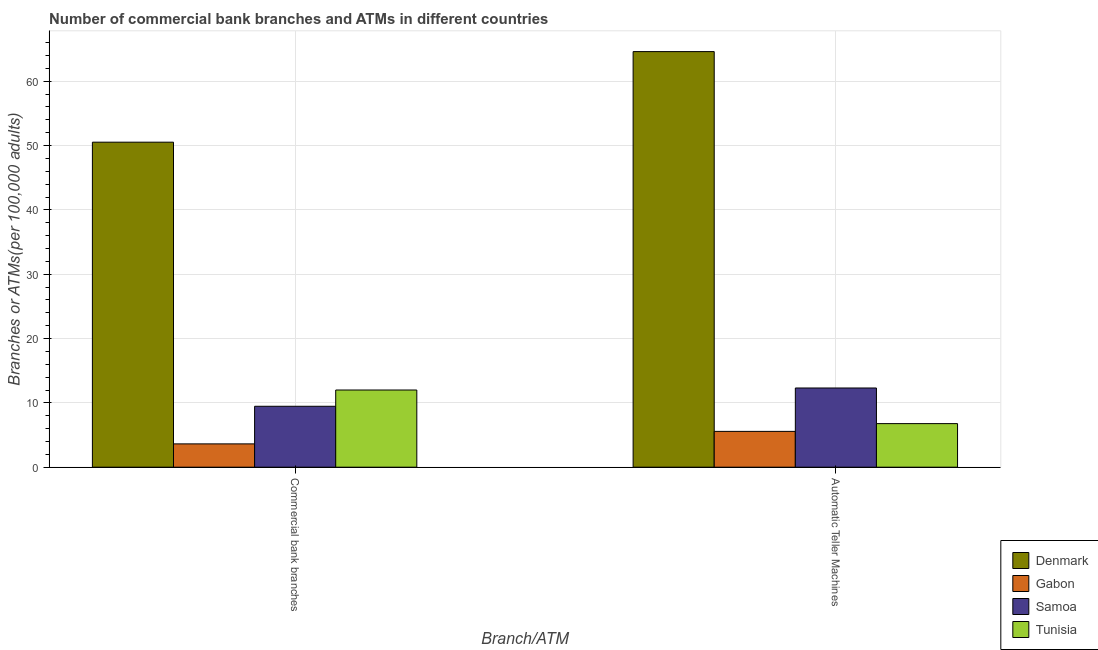How many different coloured bars are there?
Your response must be concise. 4. How many groups of bars are there?
Your answer should be very brief. 2. Are the number of bars per tick equal to the number of legend labels?
Provide a short and direct response. Yes. Are the number of bars on each tick of the X-axis equal?
Your answer should be very brief. Yes. How many bars are there on the 1st tick from the left?
Provide a short and direct response. 4. How many bars are there on the 2nd tick from the right?
Your answer should be very brief. 4. What is the label of the 2nd group of bars from the left?
Ensure brevity in your answer.  Automatic Teller Machines. What is the number of atms in Tunisia?
Provide a succinct answer. 6.78. Across all countries, what is the maximum number of atms?
Give a very brief answer. 64.61. Across all countries, what is the minimum number of atms?
Give a very brief answer. 5.57. In which country was the number of commercal bank branches maximum?
Your response must be concise. Denmark. In which country was the number of atms minimum?
Provide a succinct answer. Gabon. What is the total number of atms in the graph?
Provide a short and direct response. 89.26. What is the difference between the number of commercal bank branches in Denmark and that in Samoa?
Provide a succinct answer. 41.05. What is the difference between the number of atms in Samoa and the number of commercal bank branches in Gabon?
Keep it short and to the point. 8.69. What is the average number of commercal bank branches per country?
Give a very brief answer. 18.91. What is the difference between the number of commercal bank branches and number of atms in Samoa?
Offer a terse response. -2.84. What is the ratio of the number of atms in Tunisia to that in Samoa?
Make the answer very short. 0.55. In how many countries, is the number of atms greater than the average number of atms taken over all countries?
Your answer should be very brief. 1. What does the 1st bar from the left in Automatic Teller Machines represents?
Keep it short and to the point. Denmark. What does the 1st bar from the right in Automatic Teller Machines represents?
Provide a succinct answer. Tunisia. How many bars are there?
Your answer should be very brief. 8. Where does the legend appear in the graph?
Give a very brief answer. Bottom right. What is the title of the graph?
Offer a very short reply. Number of commercial bank branches and ATMs in different countries. Does "Tajikistan" appear as one of the legend labels in the graph?
Your response must be concise. No. What is the label or title of the X-axis?
Keep it short and to the point. Branch/ATM. What is the label or title of the Y-axis?
Offer a terse response. Branches or ATMs(per 100,0 adults). What is the Branches or ATMs(per 100,000 adults) of Denmark in Commercial bank branches?
Give a very brief answer. 50.53. What is the Branches or ATMs(per 100,000 adults) of Gabon in Commercial bank branches?
Keep it short and to the point. 3.62. What is the Branches or ATMs(per 100,000 adults) of Samoa in Commercial bank branches?
Your answer should be very brief. 9.47. What is the Branches or ATMs(per 100,000 adults) in Tunisia in Commercial bank branches?
Offer a terse response. 12. What is the Branches or ATMs(per 100,000 adults) in Denmark in Automatic Teller Machines?
Keep it short and to the point. 64.61. What is the Branches or ATMs(per 100,000 adults) of Gabon in Automatic Teller Machines?
Ensure brevity in your answer.  5.57. What is the Branches or ATMs(per 100,000 adults) in Samoa in Automatic Teller Machines?
Make the answer very short. 12.31. What is the Branches or ATMs(per 100,000 adults) of Tunisia in Automatic Teller Machines?
Keep it short and to the point. 6.78. Across all Branch/ATM, what is the maximum Branches or ATMs(per 100,000 adults) of Denmark?
Your answer should be compact. 64.61. Across all Branch/ATM, what is the maximum Branches or ATMs(per 100,000 adults) in Gabon?
Your answer should be compact. 5.57. Across all Branch/ATM, what is the maximum Branches or ATMs(per 100,000 adults) in Samoa?
Your answer should be very brief. 12.31. Across all Branch/ATM, what is the maximum Branches or ATMs(per 100,000 adults) in Tunisia?
Your answer should be very brief. 12. Across all Branch/ATM, what is the minimum Branches or ATMs(per 100,000 adults) of Denmark?
Make the answer very short. 50.53. Across all Branch/ATM, what is the minimum Branches or ATMs(per 100,000 adults) of Gabon?
Offer a terse response. 3.62. Across all Branch/ATM, what is the minimum Branches or ATMs(per 100,000 adults) of Samoa?
Ensure brevity in your answer.  9.47. Across all Branch/ATM, what is the minimum Branches or ATMs(per 100,000 adults) of Tunisia?
Make the answer very short. 6.78. What is the total Branches or ATMs(per 100,000 adults) in Denmark in the graph?
Provide a short and direct response. 115.13. What is the total Branches or ATMs(per 100,000 adults) of Gabon in the graph?
Offer a terse response. 9.19. What is the total Branches or ATMs(per 100,000 adults) in Samoa in the graph?
Your answer should be compact. 21.79. What is the total Branches or ATMs(per 100,000 adults) of Tunisia in the graph?
Ensure brevity in your answer.  18.78. What is the difference between the Branches or ATMs(per 100,000 adults) in Denmark in Commercial bank branches and that in Automatic Teller Machines?
Your answer should be very brief. -14.08. What is the difference between the Branches or ATMs(per 100,000 adults) in Gabon in Commercial bank branches and that in Automatic Teller Machines?
Your answer should be compact. -1.94. What is the difference between the Branches or ATMs(per 100,000 adults) of Samoa in Commercial bank branches and that in Automatic Teller Machines?
Provide a succinct answer. -2.84. What is the difference between the Branches or ATMs(per 100,000 adults) in Tunisia in Commercial bank branches and that in Automatic Teller Machines?
Your response must be concise. 5.22. What is the difference between the Branches or ATMs(per 100,000 adults) in Denmark in Commercial bank branches and the Branches or ATMs(per 100,000 adults) in Gabon in Automatic Teller Machines?
Provide a succinct answer. 44.96. What is the difference between the Branches or ATMs(per 100,000 adults) in Denmark in Commercial bank branches and the Branches or ATMs(per 100,000 adults) in Samoa in Automatic Teller Machines?
Ensure brevity in your answer.  38.21. What is the difference between the Branches or ATMs(per 100,000 adults) of Denmark in Commercial bank branches and the Branches or ATMs(per 100,000 adults) of Tunisia in Automatic Teller Machines?
Provide a short and direct response. 43.75. What is the difference between the Branches or ATMs(per 100,000 adults) in Gabon in Commercial bank branches and the Branches or ATMs(per 100,000 adults) in Samoa in Automatic Teller Machines?
Offer a very short reply. -8.69. What is the difference between the Branches or ATMs(per 100,000 adults) of Gabon in Commercial bank branches and the Branches or ATMs(per 100,000 adults) of Tunisia in Automatic Teller Machines?
Keep it short and to the point. -3.15. What is the difference between the Branches or ATMs(per 100,000 adults) of Samoa in Commercial bank branches and the Branches or ATMs(per 100,000 adults) of Tunisia in Automatic Teller Machines?
Give a very brief answer. 2.7. What is the average Branches or ATMs(per 100,000 adults) in Denmark per Branch/ATM?
Your response must be concise. 57.57. What is the average Branches or ATMs(per 100,000 adults) of Gabon per Branch/ATM?
Provide a succinct answer. 4.6. What is the average Branches or ATMs(per 100,000 adults) in Samoa per Branch/ATM?
Provide a succinct answer. 10.89. What is the average Branches or ATMs(per 100,000 adults) in Tunisia per Branch/ATM?
Give a very brief answer. 9.39. What is the difference between the Branches or ATMs(per 100,000 adults) of Denmark and Branches or ATMs(per 100,000 adults) of Gabon in Commercial bank branches?
Provide a short and direct response. 46.9. What is the difference between the Branches or ATMs(per 100,000 adults) in Denmark and Branches or ATMs(per 100,000 adults) in Samoa in Commercial bank branches?
Offer a very short reply. 41.05. What is the difference between the Branches or ATMs(per 100,000 adults) in Denmark and Branches or ATMs(per 100,000 adults) in Tunisia in Commercial bank branches?
Ensure brevity in your answer.  38.53. What is the difference between the Branches or ATMs(per 100,000 adults) of Gabon and Branches or ATMs(per 100,000 adults) of Samoa in Commercial bank branches?
Offer a very short reply. -5.85. What is the difference between the Branches or ATMs(per 100,000 adults) in Gabon and Branches or ATMs(per 100,000 adults) in Tunisia in Commercial bank branches?
Offer a terse response. -8.38. What is the difference between the Branches or ATMs(per 100,000 adults) of Samoa and Branches or ATMs(per 100,000 adults) of Tunisia in Commercial bank branches?
Offer a very short reply. -2.53. What is the difference between the Branches or ATMs(per 100,000 adults) in Denmark and Branches or ATMs(per 100,000 adults) in Gabon in Automatic Teller Machines?
Keep it short and to the point. 59.04. What is the difference between the Branches or ATMs(per 100,000 adults) in Denmark and Branches or ATMs(per 100,000 adults) in Samoa in Automatic Teller Machines?
Your answer should be very brief. 52.29. What is the difference between the Branches or ATMs(per 100,000 adults) of Denmark and Branches or ATMs(per 100,000 adults) of Tunisia in Automatic Teller Machines?
Make the answer very short. 57.83. What is the difference between the Branches or ATMs(per 100,000 adults) in Gabon and Branches or ATMs(per 100,000 adults) in Samoa in Automatic Teller Machines?
Your response must be concise. -6.75. What is the difference between the Branches or ATMs(per 100,000 adults) of Gabon and Branches or ATMs(per 100,000 adults) of Tunisia in Automatic Teller Machines?
Your answer should be very brief. -1.21. What is the difference between the Branches or ATMs(per 100,000 adults) in Samoa and Branches or ATMs(per 100,000 adults) in Tunisia in Automatic Teller Machines?
Offer a very short reply. 5.54. What is the ratio of the Branches or ATMs(per 100,000 adults) in Denmark in Commercial bank branches to that in Automatic Teller Machines?
Keep it short and to the point. 0.78. What is the ratio of the Branches or ATMs(per 100,000 adults) in Gabon in Commercial bank branches to that in Automatic Teller Machines?
Make the answer very short. 0.65. What is the ratio of the Branches or ATMs(per 100,000 adults) of Samoa in Commercial bank branches to that in Automatic Teller Machines?
Provide a short and direct response. 0.77. What is the ratio of the Branches or ATMs(per 100,000 adults) in Tunisia in Commercial bank branches to that in Automatic Teller Machines?
Your response must be concise. 1.77. What is the difference between the highest and the second highest Branches or ATMs(per 100,000 adults) in Denmark?
Give a very brief answer. 14.08. What is the difference between the highest and the second highest Branches or ATMs(per 100,000 adults) of Gabon?
Your response must be concise. 1.94. What is the difference between the highest and the second highest Branches or ATMs(per 100,000 adults) in Samoa?
Offer a terse response. 2.84. What is the difference between the highest and the second highest Branches or ATMs(per 100,000 adults) of Tunisia?
Provide a short and direct response. 5.22. What is the difference between the highest and the lowest Branches or ATMs(per 100,000 adults) in Denmark?
Your response must be concise. 14.08. What is the difference between the highest and the lowest Branches or ATMs(per 100,000 adults) of Gabon?
Provide a succinct answer. 1.94. What is the difference between the highest and the lowest Branches or ATMs(per 100,000 adults) of Samoa?
Provide a succinct answer. 2.84. What is the difference between the highest and the lowest Branches or ATMs(per 100,000 adults) of Tunisia?
Offer a very short reply. 5.22. 